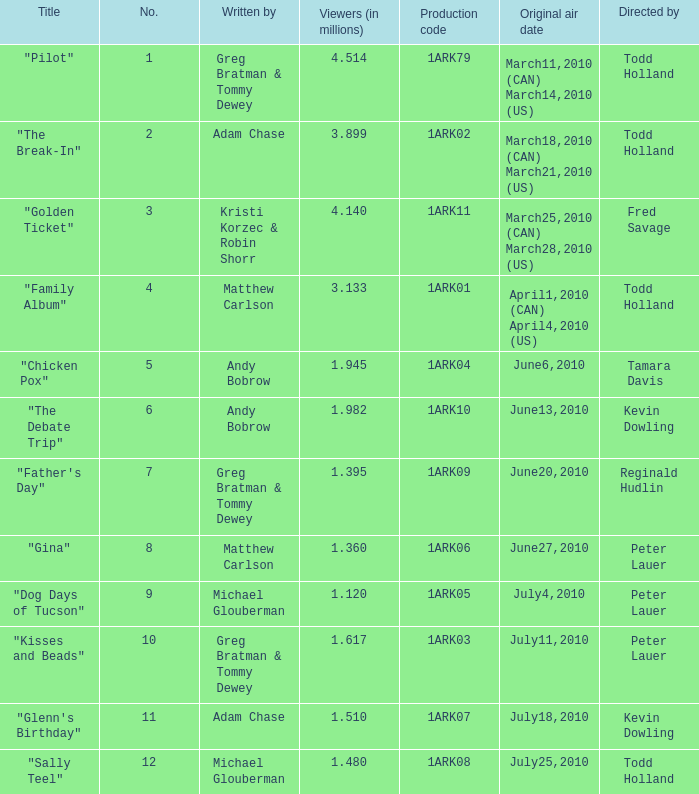List all who wrote for production code 1ark07. Adam Chase. 